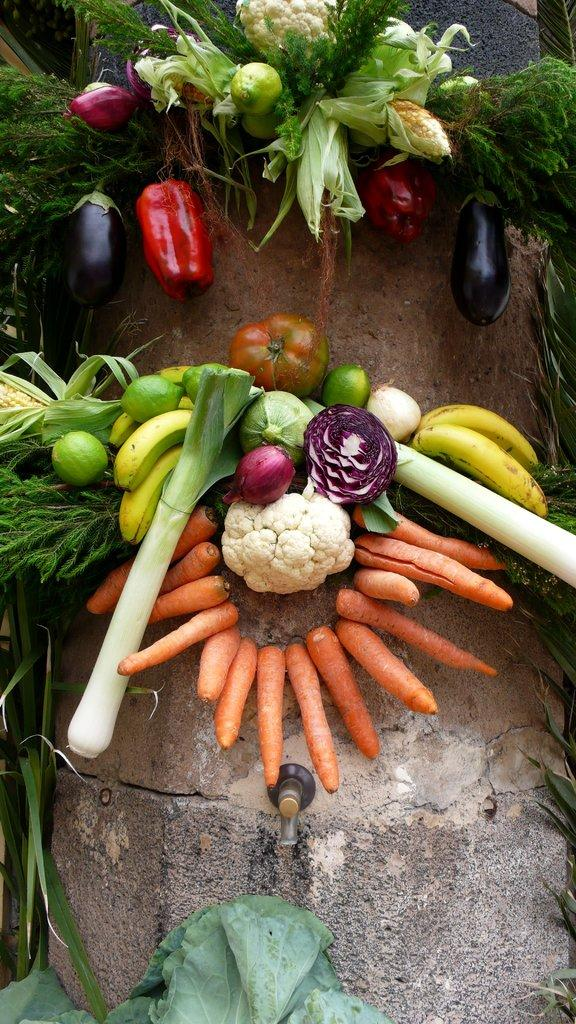What type of food can be seen in the image? The image contains raw vegetables. What side of the page is the control panel located on in the image? There is no control panel or page present in the image, as it features raw vegetables. 